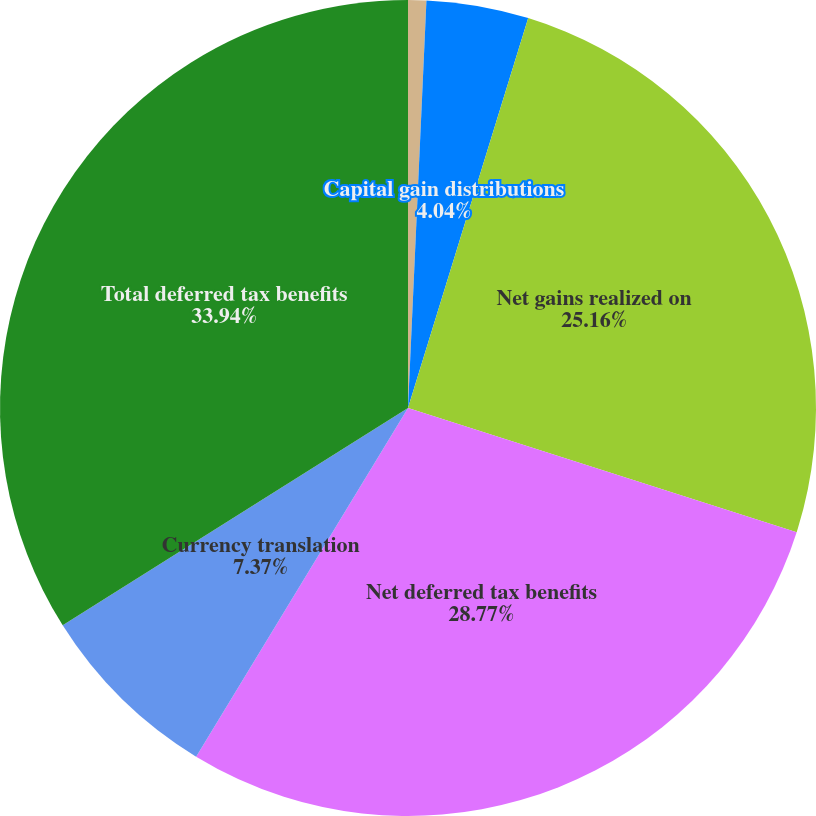<chart> <loc_0><loc_0><loc_500><loc_500><pie_chart><fcel>Net unrealized holding gains<fcel>Capital gain distributions<fcel>Net gains realized on<fcel>Net deferred tax benefits<fcel>Currency translation<fcel>Total deferred tax benefits<nl><fcel>0.72%<fcel>4.04%<fcel>25.16%<fcel>28.77%<fcel>7.37%<fcel>33.94%<nl></chart> 